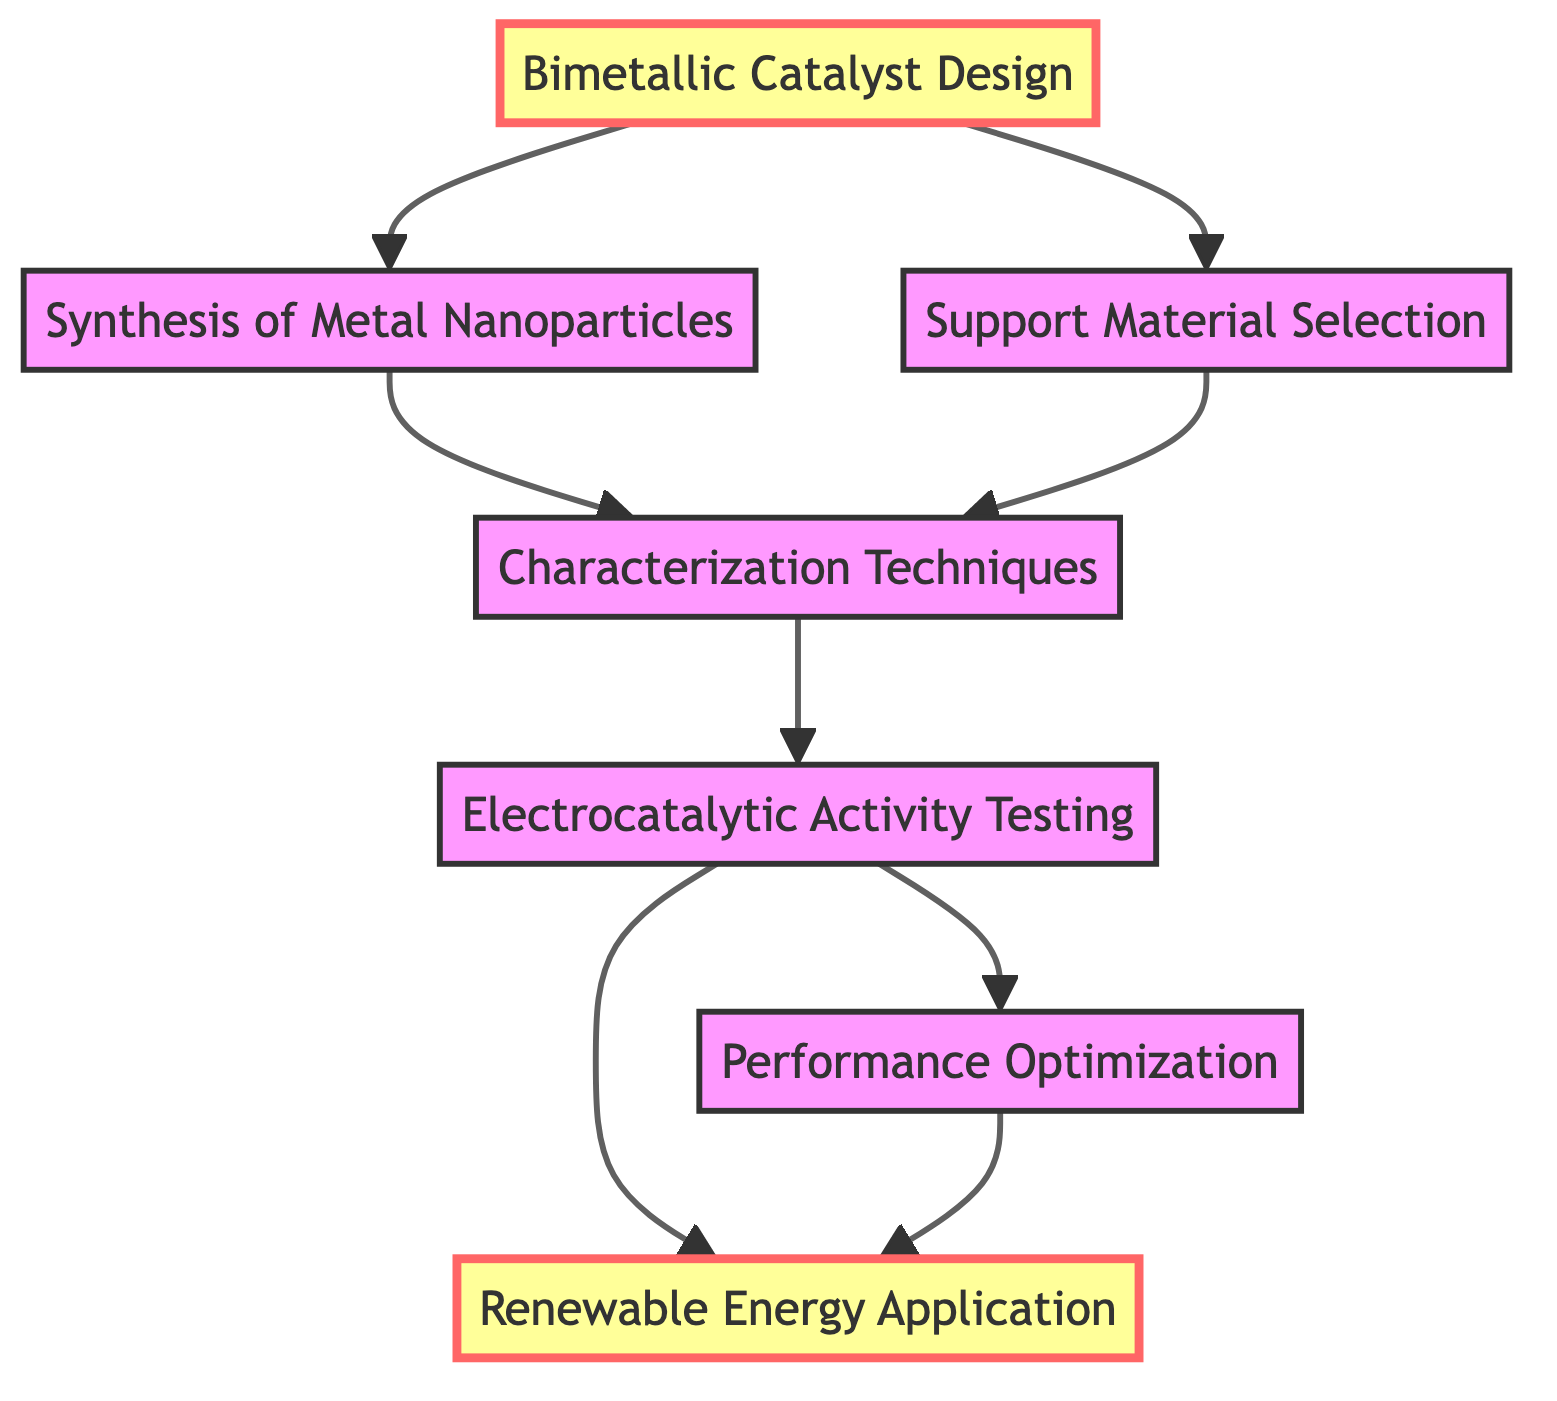What is the first step in the catalyst development pathway? The diagram indicates that the first step is "Bimetallic Catalyst Design," which is the starting node of the directed graph.
Answer: Bimetallic Catalyst Design How many nodes are present in the diagram? By counting each distinct labeled box in the diagram, we find there are seven nodes: Bimetallic Catalyst Design, Synthesis of Metal Nanoparticles, Support Material Selection, Characterization Techniques, Electrocatalytic Activity Testing, Renewable Energy Application, and Performance Optimization.
Answer: 7 What type of testing follows the characterization techniques? The arrow from "Characterization Techniques" points directly to "Electrocatalytic Activity Testing," indicating that this is the subsequent step in the pathway.
Answer: Electrocatalytic Activity Testing Which node leads to both renewable energy application and performance optimization? The node "Electrocatalytic Activity Testing" branches out to both "Renewable Energy Application" and "Performance Optimization," as shown by the two outgoing arrows.
Answer: Electrocatalytic Activity Testing What is the last step in the directed graph for the renewable energy process? Tracing the pathways leads to "Renewable Energy Application," which is the final node as it has no outgoing edges.
Answer: Renewable Energy Application How many edges connect the nodes in the pathway? By counting the arrows linking each node, we determine that there are eight edges connecting the seven nodes, representing the relationships between the steps in the process.
Answer: 8 Which steps are directly connected to the bimetallic catalyst design? The diagram shows that "Synthesis of Metal Nanoparticles" and "Support Material Selection" are both directly connected to "Bimetallic Catalyst Design," indicated by the arrows leading from it to these two nodes.
Answer: Synthesis of Metal Nanoparticles, Support Material Selection What is the direct relationship between performance optimization and renewable energy application? The arrow from "Performance Optimization" points to "Renewable Energy Application," indicating that after performance is optimized, it directly leads to this application in renewable energy.
Answer: Performance Optimization What nodes precede characterization techniques? The nodes that lead into "Characterization Techniques" are "Synthesis of Metal Nanoparticles" and "Support Material Selection," as both have edges pointing to this node.
Answer: Synthesis of Metal Nanoparticles, Support Material Selection 